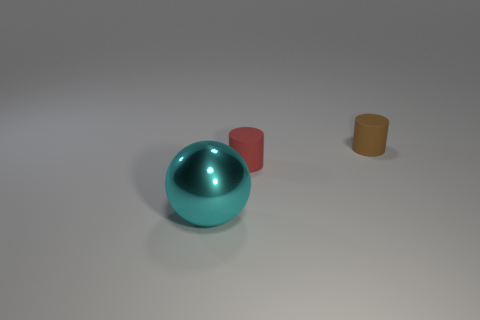What materials do these objects look like they're made from? The sphere appears to have a reflective surface, possibly indicating that it is made of a polished metal or a glossy plastic. The two cylinders seem to have a matte finish, suggesting they could be made of a rubber or plastic material; the brown one looks particularly like it could be rubber. 